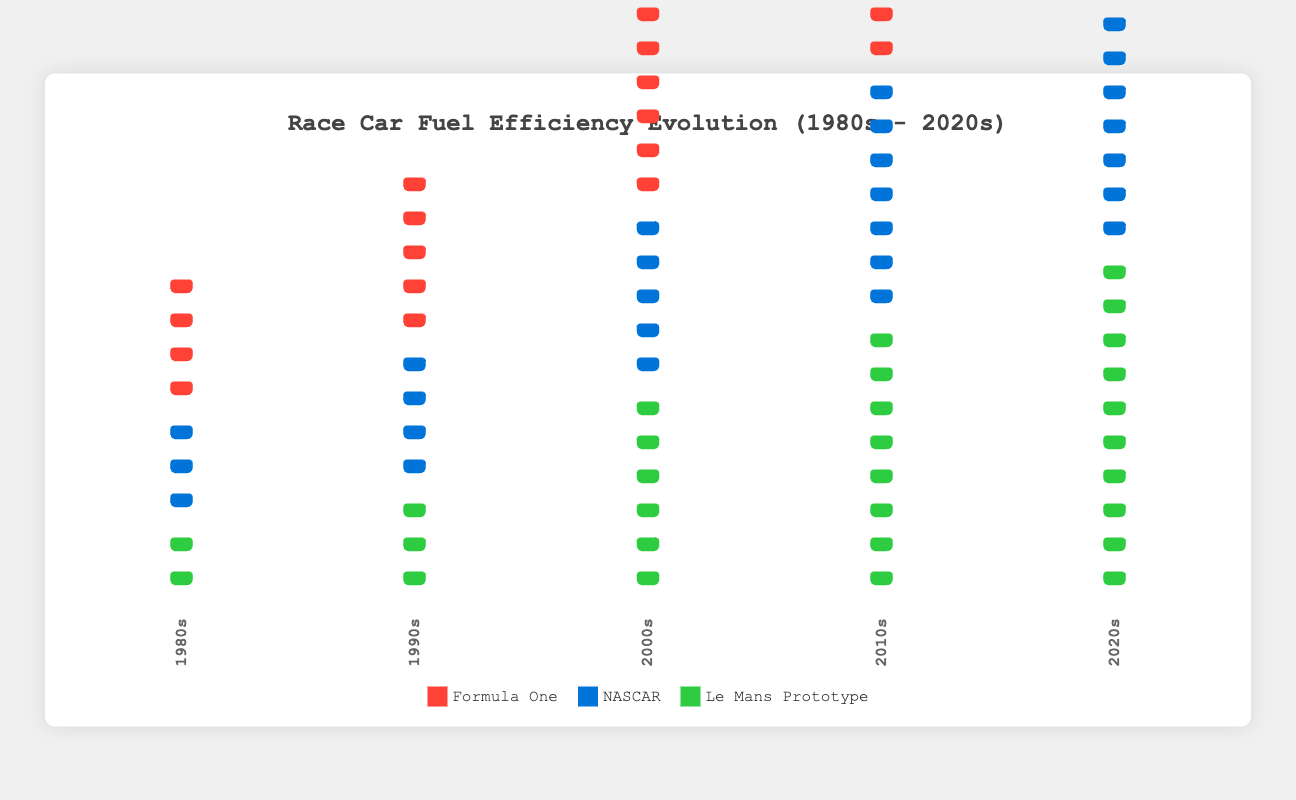What types of race cars are compared in the figure? The figure compares three types of race cars: Formula One, NASCAR, and Le Mans Prototype, as indicated by the legends and the distinct icons.
Answer: Formula One, NASCAR, Le Mans Prototype What is the title of the figure? The title is displayed prominently at the top of the figure. It reads "Race Car Fuel Efficiency Evolution (1980s - 2020s)".
Answer: Race Car Fuel Efficiency Evolution (1980s - 2020s) How has the fuel efficiency of Formula One cars changed from the 1980s to the 2020s? To determine the change, count the number of Formula One icons for each decade. In the 1980s there are 4, and in the 2020s there are 11. Thus, the fuel efficiency has increased by 7.
Answer: Increased by 7 Among the three types of cars, which had the highest fuel efficiency in the 1990s? Look at the count of icons for each car type in the 1990s. Formula One has 5 icons, NASCAR has 4, and Le Mans Prototype has 3. Formula One has the highest efficiency.
Answer: Formula One By how many units did the fuel efficiency of NASCAR cars increase from the 2000s to the 2010s? Count the number of NASCAR icons in both decades. In the 2000s, NASCAR has 5 icons, and in the 2010s, it has 7 icons. The increase is 7 - 5 = 2 units.
Answer: 2 units Compare the overall trends in fuel efficiency among the three car types over the decades. What can you conclude? To compare the trends, observe the change in the number of car icons for each type from the 1980s to the 2020s: Formula One goes from 4 to 11, NASCAR from 3 to 9, and Le Mans Prototype from 2 to 10. All types show a significant upward trend in fuel efficiency.
Answer: All types show an upward trend Which decade saw the largest increase in fuel efficiency for Le Mans Prototype cars? Observe the increase in Le Mans Prototype icons from each previous decade to the following decade: 1980s to 1990s (2 to 3), 1990s to 2000s (3 to 6), 2000s to 2010s (6 to 8), 2010s to 2020s (8 to 10). The largest increase is from the 1990s to the 2000s (3 units).
Answer: 1990s to 2000s What is the most fuel-efficient car type in the 2020s? Count the icons for each car type in the 2020s: Formula One has 11, NASCAR has 9, and Le Mans Prototype has 10. The most fuel-efficient is Formula One with 11 icons.
Answer: Formula One What is the cumulative fuel efficiency of all car types in the 2010s? Add the icons for each car type in the 2010s: Formula One (9), NASCAR (7), and Le Mans Prototype (8). The sum is 9 + 7 + 8 = 24 units.
Answer: 24 units 